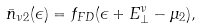Convert formula to latex. <formula><loc_0><loc_0><loc_500><loc_500>\bar { n } _ { \nu 2 } ( \epsilon ) = f _ { F D } ( \epsilon + E _ { \perp } ^ { \nu } - \mu _ { 2 } ) ,</formula> 